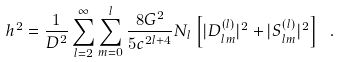<formula> <loc_0><loc_0><loc_500><loc_500>h ^ { 2 } = \frac { 1 } { D ^ { 2 } } \sum _ { l = 2 } ^ { \infty } \sum _ { m = 0 } ^ { l } \frac { 8 G ^ { 2 } } { 5 c ^ { 2 l + 4 } } N _ { l } \left [ | D ^ { ( l ) } _ { l m } | ^ { 2 } + | S _ { l m } ^ { ( l ) } | ^ { 2 } \right ] \ .</formula> 